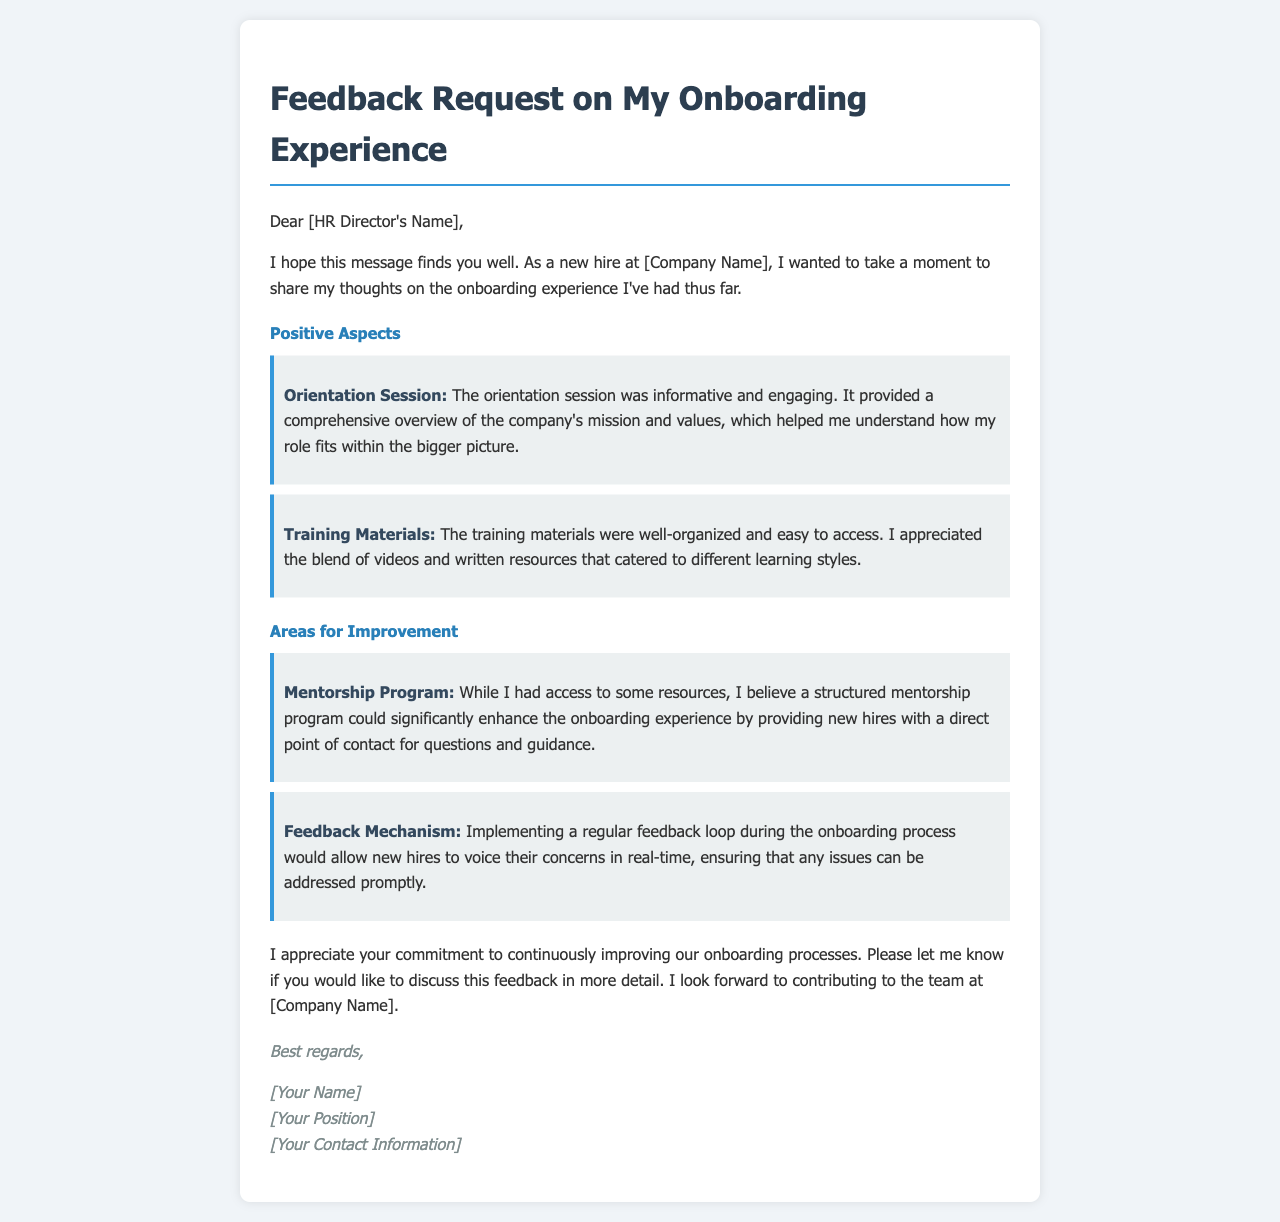What is the subject of the email? The subject of the email is explicitly stated in the title as a request for feedback regarding the onboarding experience.
Answer: Feedback Request on My Onboarding Experience Who is the email addressed to? The email is directed to the HR Director, indicated at the beginning of the message where it says "Dear [HR Director's Name]."
Answer: HR Director What aspect of onboarding does the sender mention as positive? The sender lists positive aspects, specifically highlighting the orientation session and training materials in the feedback.
Answer: Orientation Session What could enhance the onboarding experience according to the sender? The sender suggests that a mentorship program could improve the onboarding process by providing guidance for new hires.
Answer: Mentorship Program How does the sender propose to collect feedback during onboarding? The sender recommends implementing a regular feedback loop, allowing for concerns to be voiced in real-time.
Answer: Feedback Mechanism What is the sender's hope expressed in the email? The sender expresses a hope to contribute to the team, demonstrating their engagement and interest in the company's success.
Answer: Contributing to the team What document type is this email classified as? Given its content and format, this document is categorized as a feedback request email related to employee onboarding experiences.
Answer: Feedback request email 